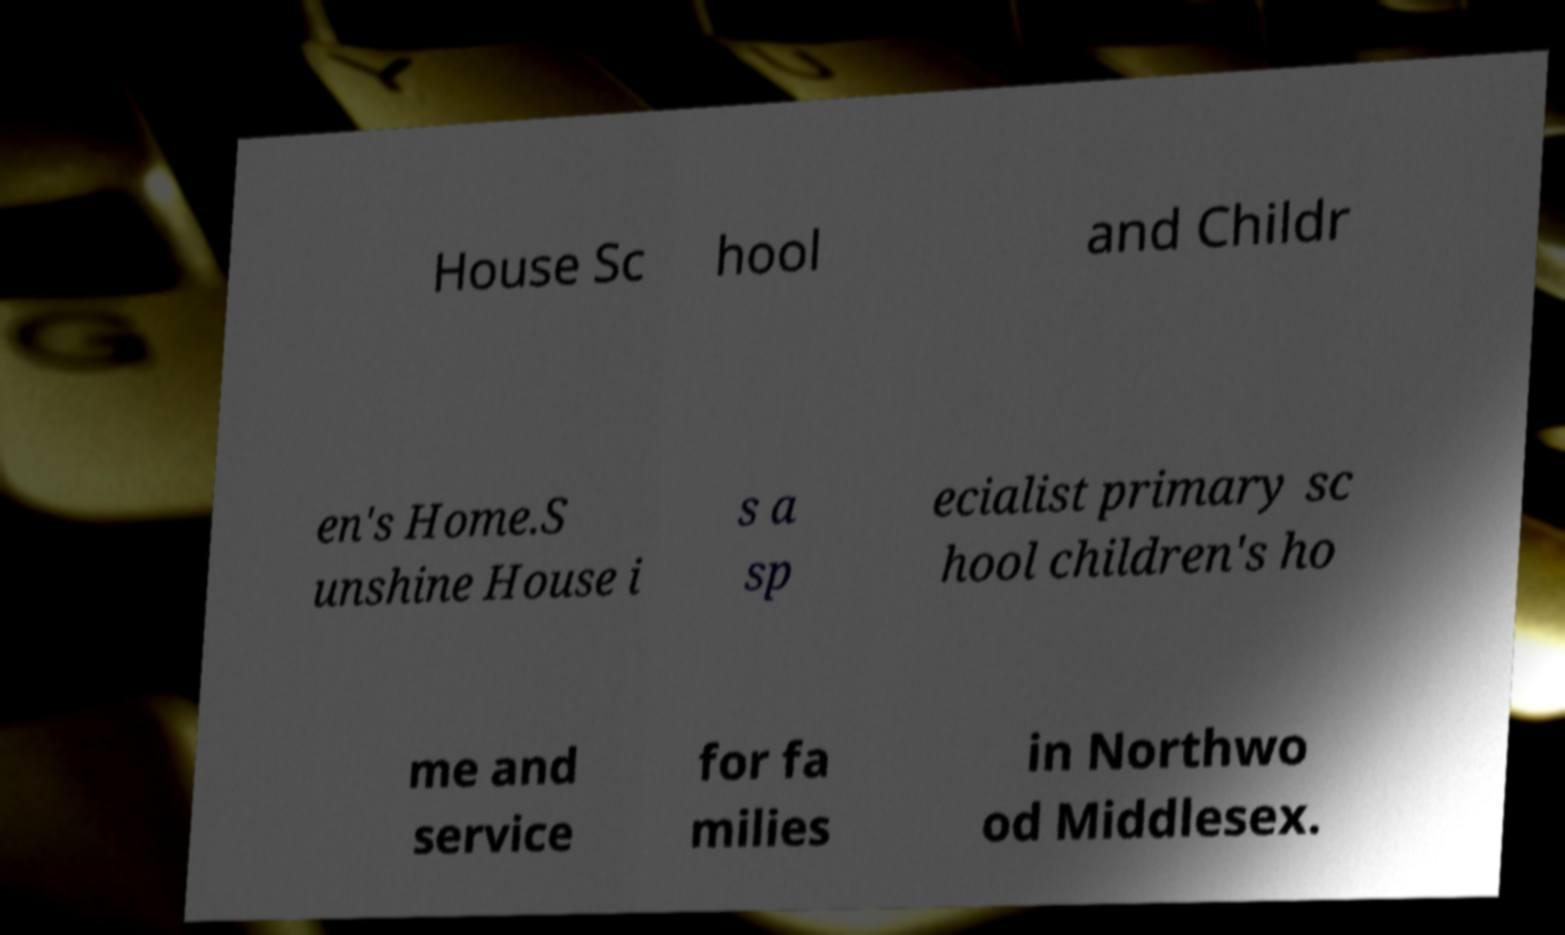Please identify and transcribe the text found in this image. House Sc hool and Childr en's Home.S unshine House i s a sp ecialist primary sc hool children's ho me and service for fa milies in Northwo od Middlesex. 